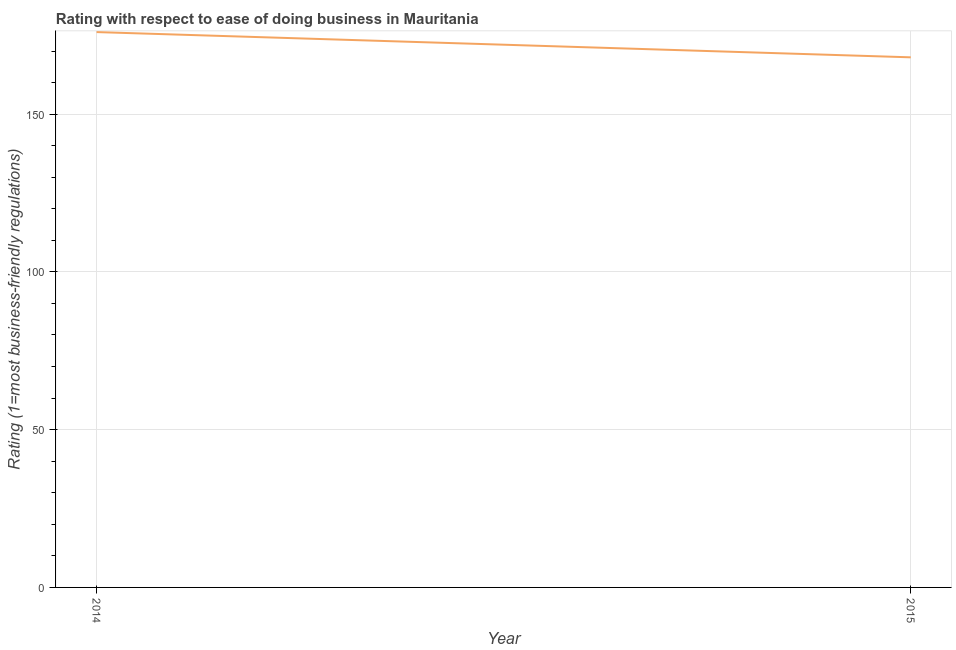What is the ease of doing business index in 2015?
Your answer should be compact. 168. Across all years, what is the maximum ease of doing business index?
Ensure brevity in your answer.  176. Across all years, what is the minimum ease of doing business index?
Your answer should be compact. 168. In which year was the ease of doing business index maximum?
Offer a very short reply. 2014. In which year was the ease of doing business index minimum?
Offer a very short reply. 2015. What is the sum of the ease of doing business index?
Offer a very short reply. 344. What is the difference between the ease of doing business index in 2014 and 2015?
Provide a short and direct response. 8. What is the average ease of doing business index per year?
Your answer should be very brief. 172. What is the median ease of doing business index?
Offer a terse response. 172. In how many years, is the ease of doing business index greater than 100 ?
Your answer should be very brief. 2. Do a majority of the years between 2015 and 2014 (inclusive) have ease of doing business index greater than 160 ?
Offer a terse response. No. What is the ratio of the ease of doing business index in 2014 to that in 2015?
Give a very brief answer. 1.05. Is the ease of doing business index in 2014 less than that in 2015?
Ensure brevity in your answer.  No. In how many years, is the ease of doing business index greater than the average ease of doing business index taken over all years?
Offer a very short reply. 1. Does the ease of doing business index monotonically increase over the years?
Your answer should be very brief. No. How many lines are there?
Your answer should be compact. 1. What is the difference between two consecutive major ticks on the Y-axis?
Keep it short and to the point. 50. Are the values on the major ticks of Y-axis written in scientific E-notation?
Keep it short and to the point. No. Does the graph contain grids?
Offer a terse response. Yes. What is the title of the graph?
Keep it short and to the point. Rating with respect to ease of doing business in Mauritania. What is the label or title of the Y-axis?
Keep it short and to the point. Rating (1=most business-friendly regulations). What is the Rating (1=most business-friendly regulations) of 2014?
Provide a short and direct response. 176. What is the Rating (1=most business-friendly regulations) in 2015?
Provide a succinct answer. 168. What is the ratio of the Rating (1=most business-friendly regulations) in 2014 to that in 2015?
Give a very brief answer. 1.05. 